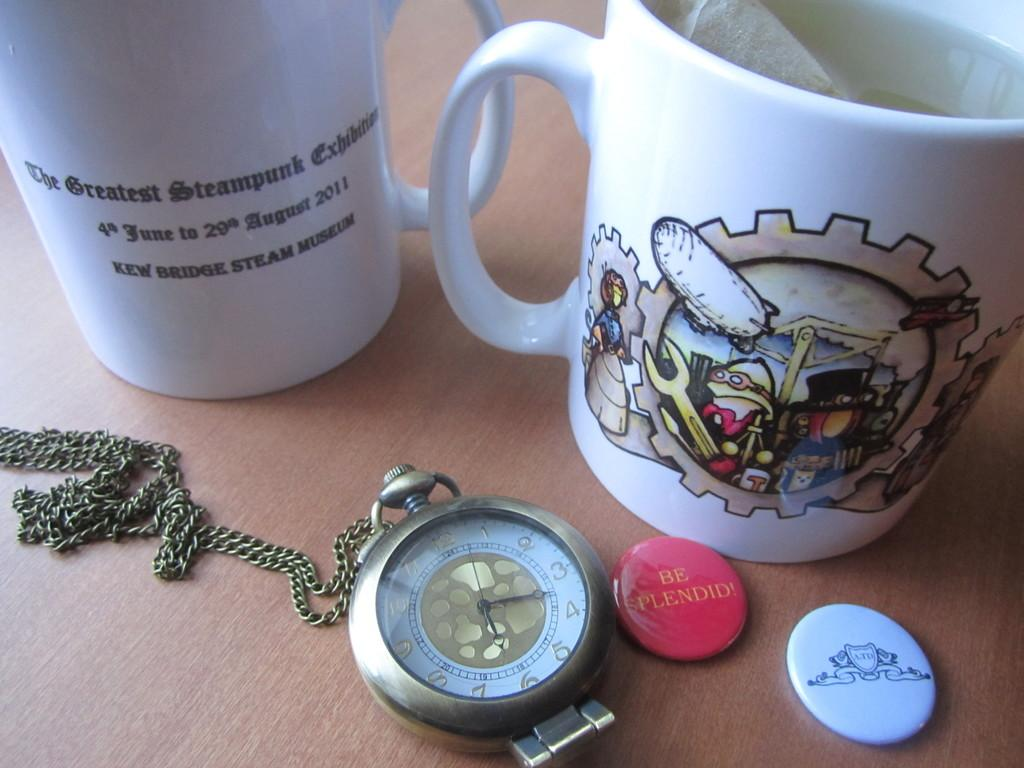<image>
Offer a succinct explanation of the picture presented. A red pin button with Be Splendid on it next to cups and a pocket watch. 